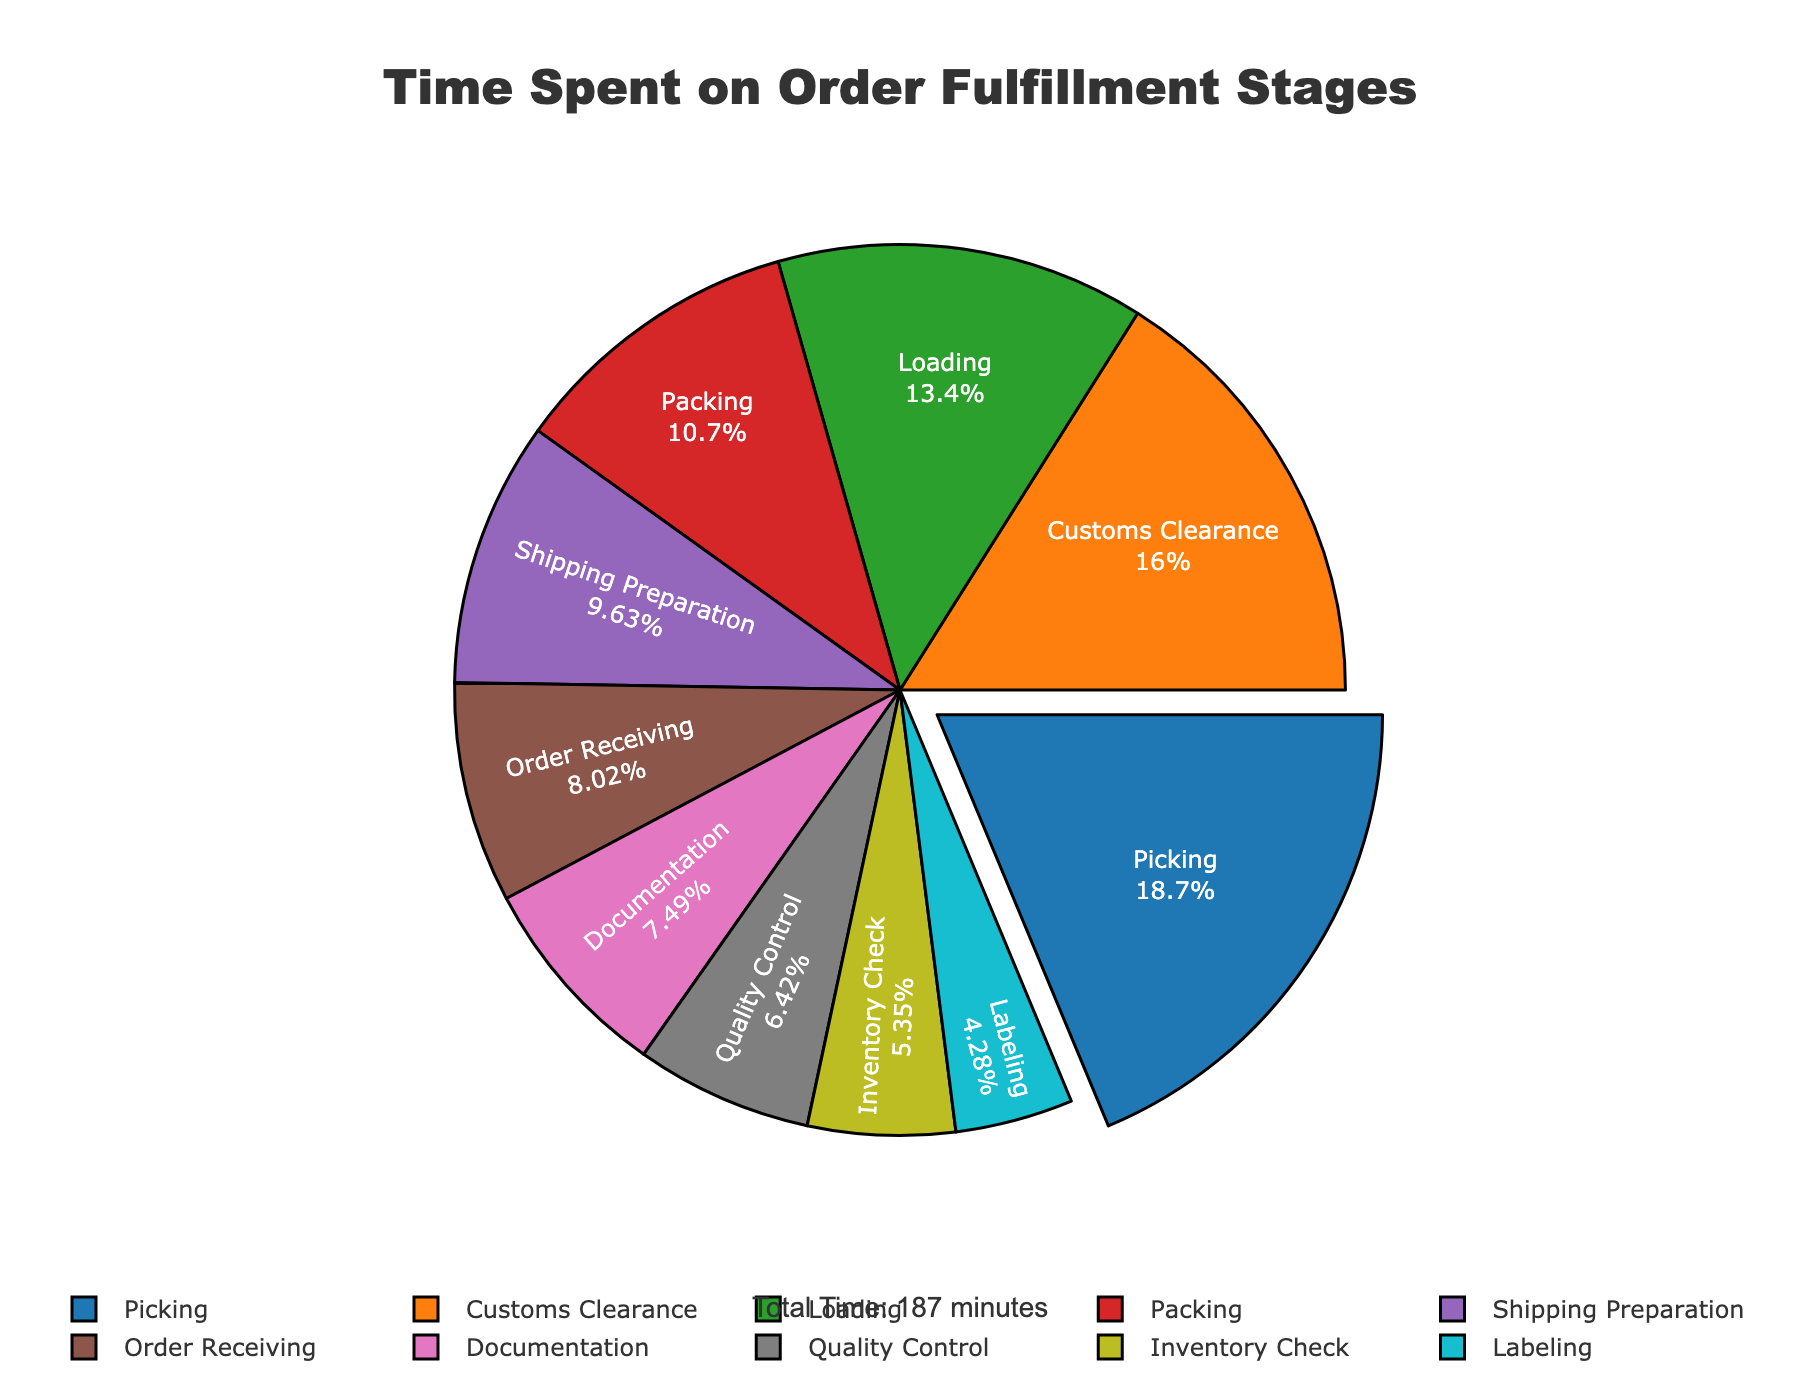Which stage takes up the most time in the order fulfillment process? The stage that takes up the most time can be identified by looking at the largest section of the pie chart, which is "Picking".
Answer: Picking Which stage is the shortest in terms of time spent? The stage that takes the shortest time can be determined by looking at the smallest section of the pie chart, which is "Labeling".
Answer: Labeling What percentage of time is spent on Customs Clearance? The percentage can be found directly from the pie chart segment labeled "Customs Clearance," which shows both the label and the percentage.
Answer: 15.0% What is the combined time spent on Packing and Quality Control? Add the time spent on Packing (20 minutes) and Quality Control (12 minutes): 20 + 12 = 32 minutes.
Answer: 32 minutes How does the time spent on Loading compare to that on Documentation? By comparing the segments, you can see that Loading takes 25 minutes while Documentation takes 14 minutes. Loading takes more time.
Answer: Loading takes more time What is the total time spent on Inventory Check, Packing, and Shipping Preparation? Add the time spent on Inventory Check (10 minutes), Packing (20 minutes), and Shipping Preparation (18 minutes): 10 + 20 + 18 = 48 minutes.
Answer: 48 minutes By how much does the time spent on Customs Clearance exceed that on Order Receiving? Subtract the time spent on Order Receiving (15 minutes) from that on Customs Clearance (30 minutes): 30 - 15 = 15 minutes.
Answer: 15 minutes Which stage has a higher percentage of total time spent: Packing or Loading? From the pie chart, compare the percentages of Packing and Loading. Packing accounts for less time than Loading.
Answer: Loading What is the average time spent on the stages of Inventory Check, Labeling, and Shipping Preparation? Add the times spent on Inventory Check (10 minutes), Labeling (8 minutes), and Shipping Preparation (18 minutes) and divide by 3: (10 + 8 + 18) / 3 ≈ 12 minutes.
Answer: 12 minutes What fraction of the total time is spent on Documentation? The total time is the sum of all the stages: 15 + 10 + 35 + 20 + 12 + 8 + 18 + 25 + 14 + 30 = 187 minutes. The fraction for Documentation is 14/187.
Answer: 14/187 